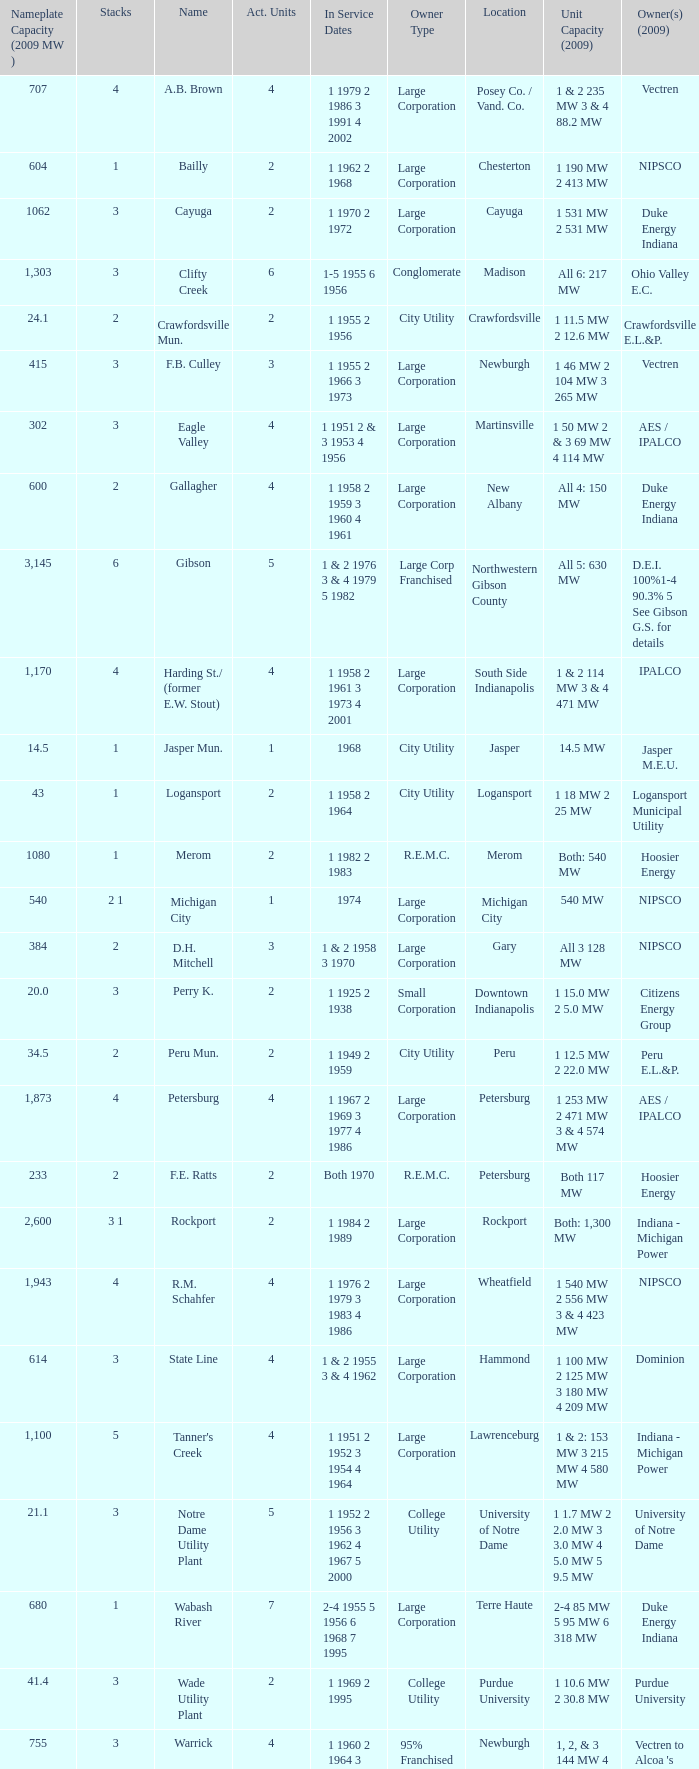Name the number for service dates for hoosier energy for petersburg 1.0. 